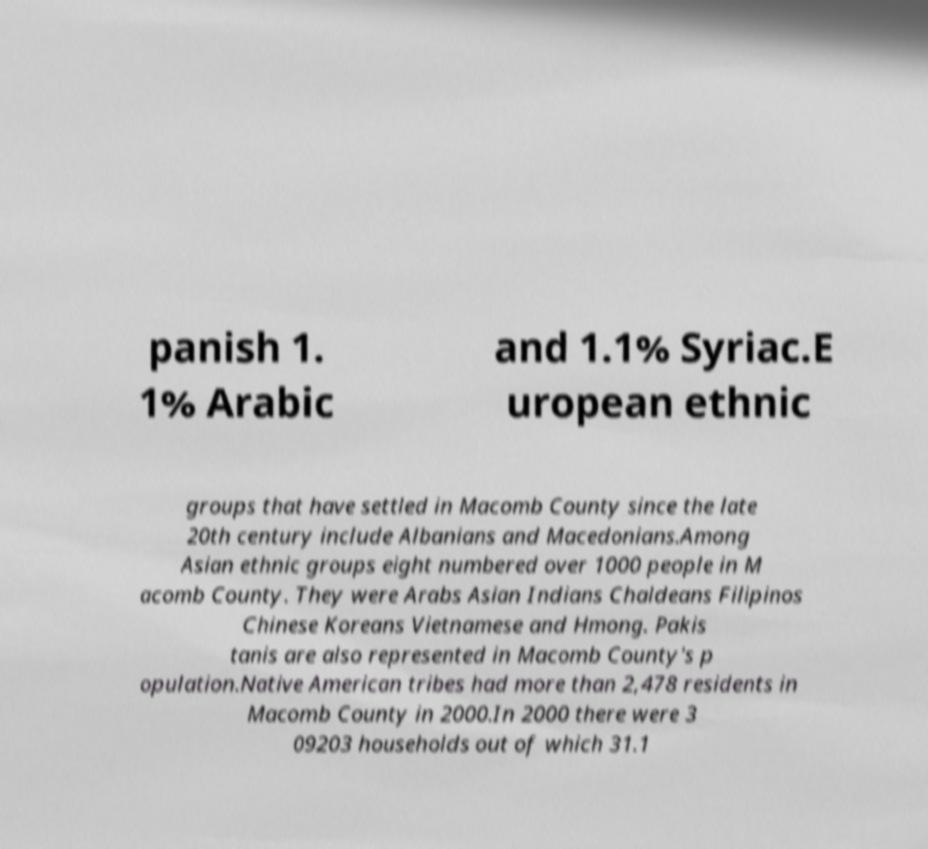Can you read and provide the text displayed in the image?This photo seems to have some interesting text. Can you extract and type it out for me? panish 1. 1% Arabic and 1.1% Syriac.E uropean ethnic groups that have settled in Macomb County since the late 20th century include Albanians and Macedonians.Among Asian ethnic groups eight numbered over 1000 people in M acomb County. They were Arabs Asian Indians Chaldeans Filipinos Chinese Koreans Vietnamese and Hmong. Pakis tanis are also represented in Macomb County's p opulation.Native American tribes had more than 2,478 residents in Macomb County in 2000.In 2000 there were 3 09203 households out of which 31.1 